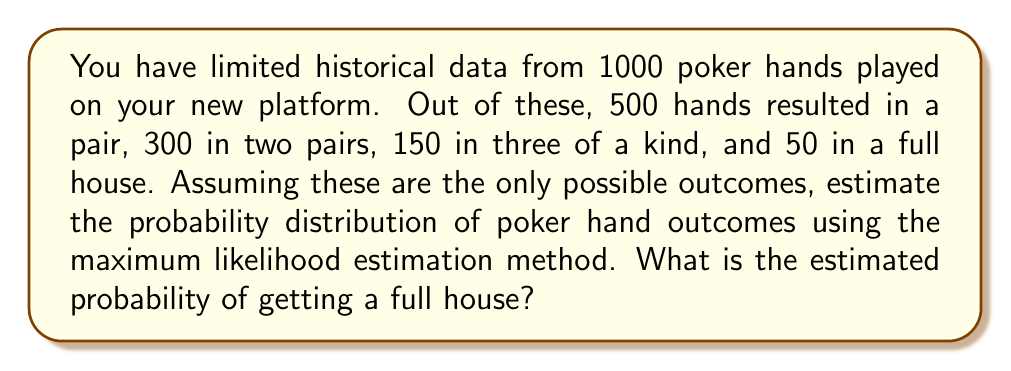Help me with this question. To estimate the probability distribution of poker hand outcomes using the maximum likelihood estimation (MLE) method, we follow these steps:

1. Define the probability parameters:
   Let $p_1$, $p_2$, $p_3$, and $p_4$ be the probabilities of getting a pair, two pairs, three of a kind, and a full house, respectively.

2. Write the likelihood function:
   $$L(p_1, p_2, p_3, p_4) = p_1^{500} \cdot p_2^{300} \cdot p_3^{150} \cdot p_4^{50}$$

3. Apply the constraint that probabilities must sum to 1:
   $$p_1 + p_2 + p_3 + p_4 = 1$$

4. Use the method of Lagrange multipliers to maximize the likelihood function subject to the constraint. However, in this case, we can use a simpler approach due to the nature of the problem.

5. The maximum likelihood estimates for multinomial probabilities are given by the relative frequencies:
   $$\hat{p_i} = \frac{n_i}{N}$$
   where $n_i$ is the number of occurrences of outcome $i$, and $N$ is the total number of trials.

6. Calculate the estimated probabilities:
   $$\hat{p_1} = \frac{500}{1000} = 0.5$$
   $$\hat{p_2} = \frac{300}{1000} = 0.3$$
   $$\hat{p_3} = \frac{150}{1000} = 0.15$$
   $$\hat{p_4} = \frac{50}{1000} = 0.05$$

7. The estimated probability of getting a full house is $\hat{p_4} = 0.05$ or 5%.
Answer: 0.05 